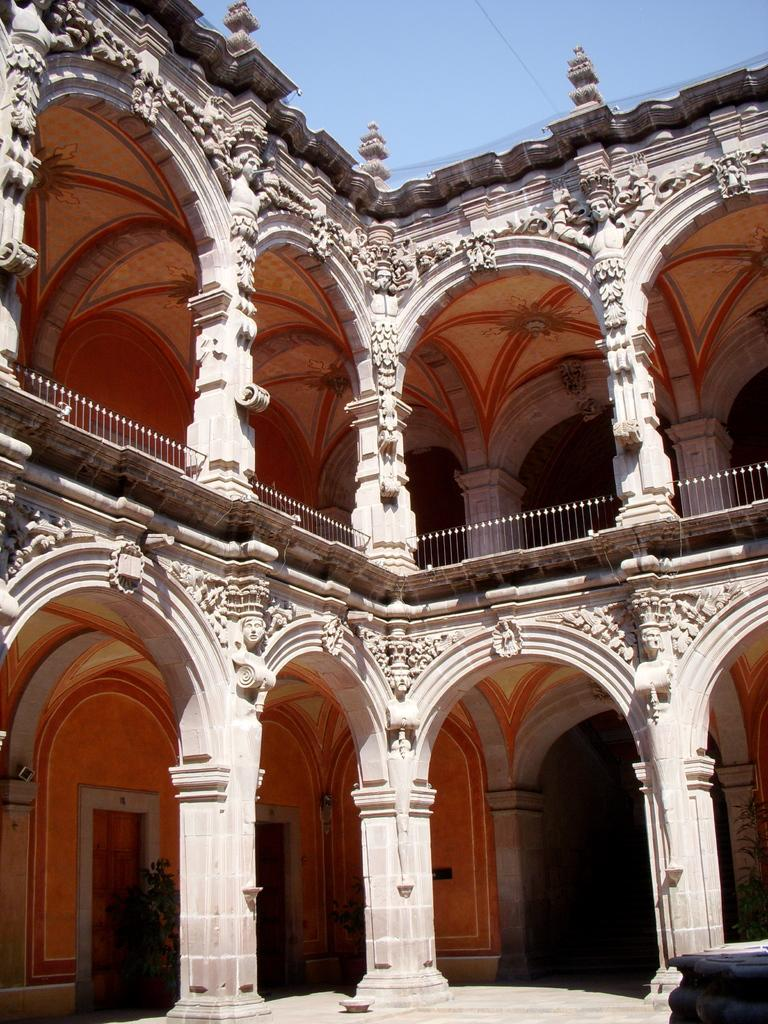What structures are located in the center of the image? There are pillars and a building in the center of the image. What can be seen in the background of the image? Sky is visible in the background of the image. How many bears are visible in the image? There are no bears present in the image. What type of collar is being worn by the building in the image? There is no collar present in the image, as buildings do not wear collars. 